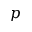<formula> <loc_0><loc_0><loc_500><loc_500>p</formula> 